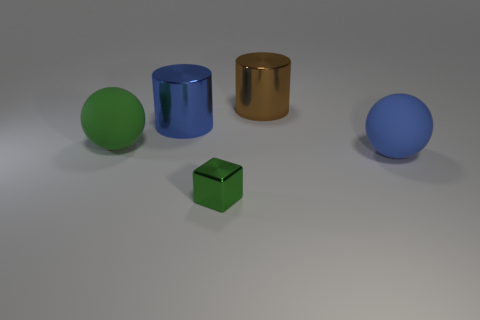What number of other things are the same color as the cube?
Keep it short and to the point. 1. What number of other things are the same material as the large green ball?
Keep it short and to the point. 1. There is a green ball; is its size the same as the blue thing on the right side of the blue shiny cylinder?
Offer a very short reply. Yes. The small cube has what color?
Make the answer very short. Green. There is a green thing behind the sphere that is right of the matte ball left of the blue ball; what shape is it?
Provide a short and direct response. Sphere. What material is the blue thing that is left of the large cylinder right of the blue cylinder made of?
Provide a short and direct response. Metal. What is the shape of the big brown object that is made of the same material as the blue cylinder?
Ensure brevity in your answer.  Cylinder. Is there any other thing that has the same shape as the blue matte object?
Your response must be concise. Yes. There is a brown metallic cylinder; how many tiny green things are to the left of it?
Make the answer very short. 1. Is there a large brown rubber cylinder?
Ensure brevity in your answer.  No. 